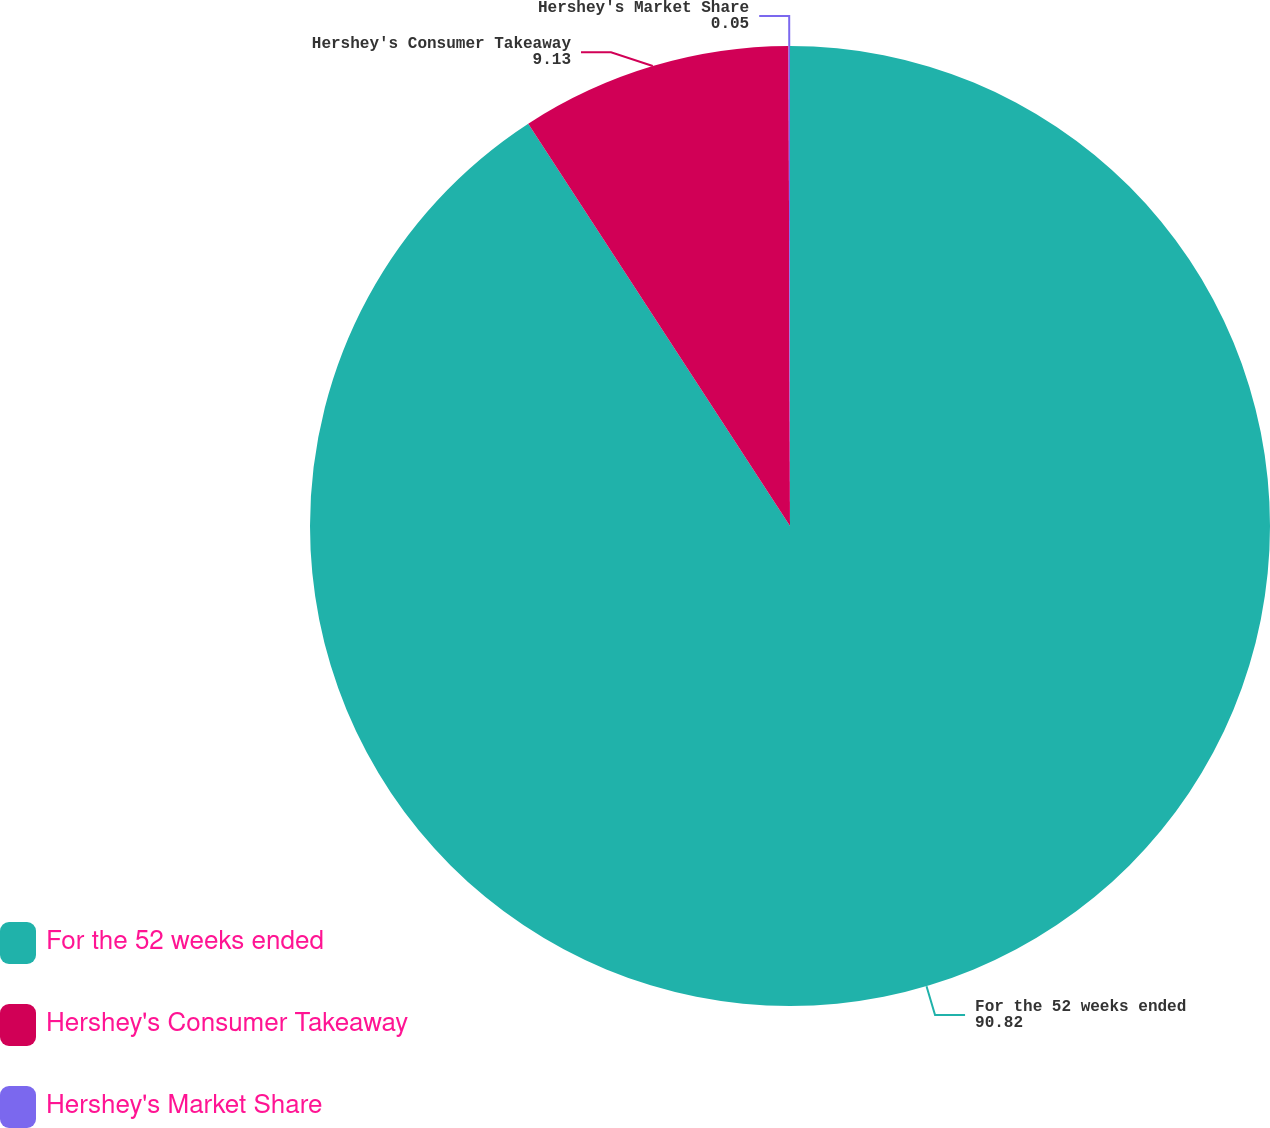Convert chart. <chart><loc_0><loc_0><loc_500><loc_500><pie_chart><fcel>For the 52 weeks ended<fcel>Hershey's Consumer Takeaway<fcel>Hershey's Market Share<nl><fcel>90.82%<fcel>9.13%<fcel>0.05%<nl></chart> 